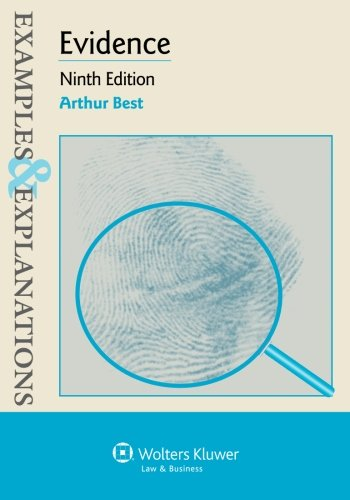Who is the publisher of this book? The publisher of the book 'Examples & Explanations: Evidence' is Wolters Kluwer, a company known for its specialized educational resources in the fields of law, business, and health. 